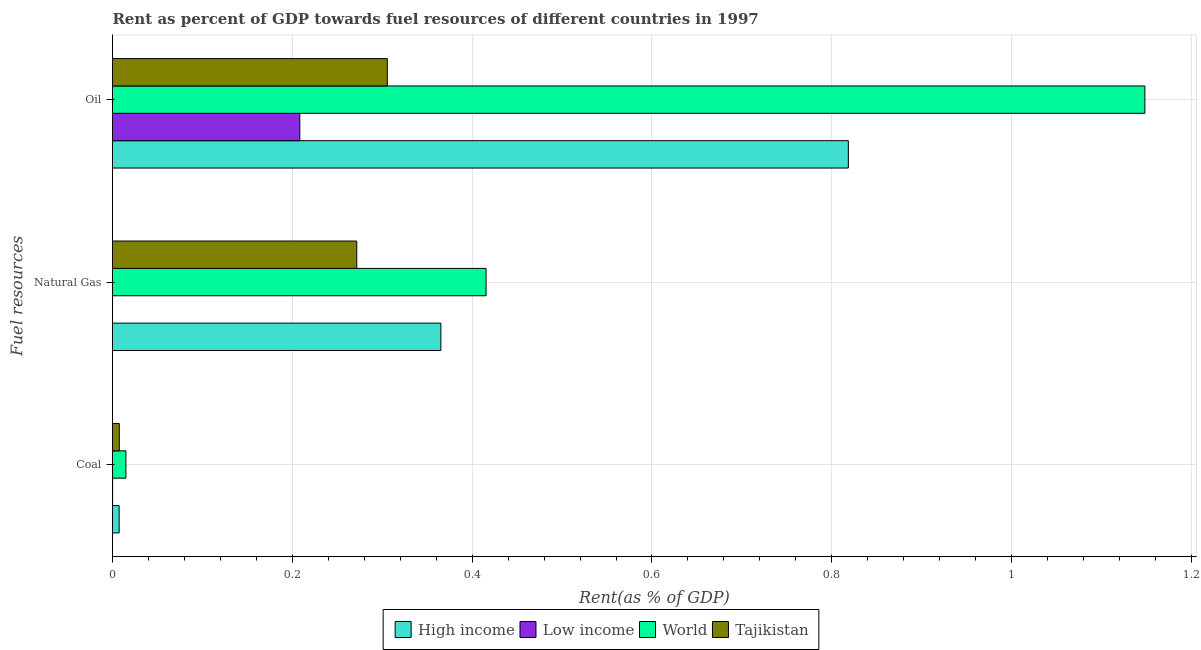How many different coloured bars are there?
Make the answer very short. 4. Are the number of bars per tick equal to the number of legend labels?
Give a very brief answer. Yes. How many bars are there on the 3rd tick from the top?
Offer a very short reply. 4. What is the label of the 2nd group of bars from the top?
Your answer should be compact. Natural Gas. What is the rent towards oil in Tajikistan?
Ensure brevity in your answer.  0.31. Across all countries, what is the maximum rent towards oil?
Offer a very short reply. 1.15. Across all countries, what is the minimum rent towards coal?
Ensure brevity in your answer.  0. In which country was the rent towards oil maximum?
Keep it short and to the point. World. In which country was the rent towards oil minimum?
Provide a short and direct response. Low income. What is the total rent towards oil in the graph?
Keep it short and to the point. 2.48. What is the difference between the rent towards natural gas in World and that in Tajikistan?
Keep it short and to the point. 0.14. What is the difference between the rent towards oil in Tajikistan and the rent towards natural gas in World?
Your answer should be very brief. -0.11. What is the average rent towards coal per country?
Ensure brevity in your answer.  0.01. What is the difference between the rent towards oil and rent towards natural gas in World?
Offer a very short reply. 0.73. What is the ratio of the rent towards natural gas in Tajikistan to that in Low income?
Your answer should be compact. 7077.59. Is the rent towards coal in Low income less than that in High income?
Provide a short and direct response. Yes. Is the difference between the rent towards natural gas in High income and Tajikistan greater than the difference between the rent towards oil in High income and Tajikistan?
Offer a very short reply. No. What is the difference between the highest and the second highest rent towards oil?
Provide a short and direct response. 0.33. What is the difference between the highest and the lowest rent towards coal?
Your response must be concise. 0.01. In how many countries, is the rent towards natural gas greater than the average rent towards natural gas taken over all countries?
Make the answer very short. 3. Is the sum of the rent towards coal in Low income and World greater than the maximum rent towards natural gas across all countries?
Give a very brief answer. No. What does the 3rd bar from the top in Natural Gas represents?
Offer a very short reply. Low income. Is it the case that in every country, the sum of the rent towards coal and rent towards natural gas is greater than the rent towards oil?
Keep it short and to the point. No. How many bars are there?
Ensure brevity in your answer.  12. How many countries are there in the graph?
Give a very brief answer. 4. Are the values on the major ticks of X-axis written in scientific E-notation?
Provide a succinct answer. No. Where does the legend appear in the graph?
Offer a terse response. Bottom center. What is the title of the graph?
Your answer should be compact. Rent as percent of GDP towards fuel resources of different countries in 1997. Does "Moldova" appear as one of the legend labels in the graph?
Offer a terse response. No. What is the label or title of the X-axis?
Your answer should be very brief. Rent(as % of GDP). What is the label or title of the Y-axis?
Your answer should be compact. Fuel resources. What is the Rent(as % of GDP) in High income in Coal?
Your answer should be very brief. 0.01. What is the Rent(as % of GDP) of Low income in Coal?
Offer a very short reply. 0. What is the Rent(as % of GDP) of World in Coal?
Your answer should be very brief. 0.01. What is the Rent(as % of GDP) in Tajikistan in Coal?
Your answer should be compact. 0.01. What is the Rent(as % of GDP) of High income in Natural Gas?
Your answer should be very brief. 0.37. What is the Rent(as % of GDP) in Low income in Natural Gas?
Provide a short and direct response. 3.83841350463664e-5. What is the Rent(as % of GDP) of World in Natural Gas?
Offer a very short reply. 0.42. What is the Rent(as % of GDP) of Tajikistan in Natural Gas?
Your answer should be compact. 0.27. What is the Rent(as % of GDP) of High income in Oil?
Provide a succinct answer. 0.82. What is the Rent(as % of GDP) of Low income in Oil?
Keep it short and to the point. 0.21. What is the Rent(as % of GDP) in World in Oil?
Your answer should be very brief. 1.15. What is the Rent(as % of GDP) of Tajikistan in Oil?
Your answer should be very brief. 0.31. Across all Fuel resources, what is the maximum Rent(as % of GDP) in High income?
Offer a terse response. 0.82. Across all Fuel resources, what is the maximum Rent(as % of GDP) of Low income?
Give a very brief answer. 0.21. Across all Fuel resources, what is the maximum Rent(as % of GDP) in World?
Ensure brevity in your answer.  1.15. Across all Fuel resources, what is the maximum Rent(as % of GDP) in Tajikistan?
Give a very brief answer. 0.31. Across all Fuel resources, what is the minimum Rent(as % of GDP) of High income?
Provide a succinct answer. 0.01. Across all Fuel resources, what is the minimum Rent(as % of GDP) of Low income?
Your response must be concise. 3.83841350463664e-5. Across all Fuel resources, what is the minimum Rent(as % of GDP) of World?
Your response must be concise. 0.01. Across all Fuel resources, what is the minimum Rent(as % of GDP) in Tajikistan?
Keep it short and to the point. 0.01. What is the total Rent(as % of GDP) in High income in the graph?
Offer a very short reply. 1.19. What is the total Rent(as % of GDP) in Low income in the graph?
Give a very brief answer. 0.21. What is the total Rent(as % of GDP) in World in the graph?
Give a very brief answer. 1.58. What is the total Rent(as % of GDP) of Tajikistan in the graph?
Your answer should be very brief. 0.58. What is the difference between the Rent(as % of GDP) of High income in Coal and that in Natural Gas?
Provide a succinct answer. -0.36. What is the difference between the Rent(as % of GDP) of World in Coal and that in Natural Gas?
Your answer should be very brief. -0.4. What is the difference between the Rent(as % of GDP) in Tajikistan in Coal and that in Natural Gas?
Make the answer very short. -0.26. What is the difference between the Rent(as % of GDP) of High income in Coal and that in Oil?
Your response must be concise. -0.81. What is the difference between the Rent(as % of GDP) of Low income in Coal and that in Oil?
Make the answer very short. -0.21. What is the difference between the Rent(as % of GDP) in World in Coal and that in Oil?
Make the answer very short. -1.13. What is the difference between the Rent(as % of GDP) of Tajikistan in Coal and that in Oil?
Ensure brevity in your answer.  -0.3. What is the difference between the Rent(as % of GDP) of High income in Natural Gas and that in Oil?
Ensure brevity in your answer.  -0.45. What is the difference between the Rent(as % of GDP) in Low income in Natural Gas and that in Oil?
Your answer should be compact. -0.21. What is the difference between the Rent(as % of GDP) in World in Natural Gas and that in Oil?
Provide a succinct answer. -0.73. What is the difference between the Rent(as % of GDP) of Tajikistan in Natural Gas and that in Oil?
Give a very brief answer. -0.03. What is the difference between the Rent(as % of GDP) of High income in Coal and the Rent(as % of GDP) of Low income in Natural Gas?
Ensure brevity in your answer.  0.01. What is the difference between the Rent(as % of GDP) in High income in Coal and the Rent(as % of GDP) in World in Natural Gas?
Your answer should be compact. -0.41. What is the difference between the Rent(as % of GDP) of High income in Coal and the Rent(as % of GDP) of Tajikistan in Natural Gas?
Provide a succinct answer. -0.26. What is the difference between the Rent(as % of GDP) in Low income in Coal and the Rent(as % of GDP) in World in Natural Gas?
Your response must be concise. -0.42. What is the difference between the Rent(as % of GDP) in Low income in Coal and the Rent(as % of GDP) in Tajikistan in Natural Gas?
Ensure brevity in your answer.  -0.27. What is the difference between the Rent(as % of GDP) of World in Coal and the Rent(as % of GDP) of Tajikistan in Natural Gas?
Your answer should be compact. -0.26. What is the difference between the Rent(as % of GDP) of High income in Coal and the Rent(as % of GDP) of Low income in Oil?
Your answer should be very brief. -0.2. What is the difference between the Rent(as % of GDP) in High income in Coal and the Rent(as % of GDP) in World in Oil?
Your answer should be compact. -1.14. What is the difference between the Rent(as % of GDP) of High income in Coal and the Rent(as % of GDP) of Tajikistan in Oil?
Ensure brevity in your answer.  -0.3. What is the difference between the Rent(as % of GDP) of Low income in Coal and the Rent(as % of GDP) of World in Oil?
Ensure brevity in your answer.  -1.15. What is the difference between the Rent(as % of GDP) of Low income in Coal and the Rent(as % of GDP) of Tajikistan in Oil?
Provide a succinct answer. -0.31. What is the difference between the Rent(as % of GDP) in World in Coal and the Rent(as % of GDP) in Tajikistan in Oil?
Provide a short and direct response. -0.29. What is the difference between the Rent(as % of GDP) of High income in Natural Gas and the Rent(as % of GDP) of Low income in Oil?
Make the answer very short. 0.16. What is the difference between the Rent(as % of GDP) in High income in Natural Gas and the Rent(as % of GDP) in World in Oil?
Ensure brevity in your answer.  -0.78. What is the difference between the Rent(as % of GDP) of High income in Natural Gas and the Rent(as % of GDP) of Tajikistan in Oil?
Provide a short and direct response. 0.06. What is the difference between the Rent(as % of GDP) in Low income in Natural Gas and the Rent(as % of GDP) in World in Oil?
Your response must be concise. -1.15. What is the difference between the Rent(as % of GDP) in Low income in Natural Gas and the Rent(as % of GDP) in Tajikistan in Oil?
Ensure brevity in your answer.  -0.31. What is the difference between the Rent(as % of GDP) of World in Natural Gas and the Rent(as % of GDP) of Tajikistan in Oil?
Provide a short and direct response. 0.11. What is the average Rent(as % of GDP) of High income per Fuel resources?
Your answer should be compact. 0.4. What is the average Rent(as % of GDP) in Low income per Fuel resources?
Offer a terse response. 0.07. What is the average Rent(as % of GDP) in World per Fuel resources?
Your answer should be very brief. 0.53. What is the average Rent(as % of GDP) in Tajikistan per Fuel resources?
Your answer should be very brief. 0.2. What is the difference between the Rent(as % of GDP) in High income and Rent(as % of GDP) in Low income in Coal?
Provide a short and direct response. 0.01. What is the difference between the Rent(as % of GDP) in High income and Rent(as % of GDP) in World in Coal?
Your answer should be very brief. -0.01. What is the difference between the Rent(as % of GDP) in High income and Rent(as % of GDP) in Tajikistan in Coal?
Your response must be concise. -0. What is the difference between the Rent(as % of GDP) of Low income and Rent(as % of GDP) of World in Coal?
Your response must be concise. -0.01. What is the difference between the Rent(as % of GDP) of Low income and Rent(as % of GDP) of Tajikistan in Coal?
Give a very brief answer. -0.01. What is the difference between the Rent(as % of GDP) of World and Rent(as % of GDP) of Tajikistan in Coal?
Keep it short and to the point. 0.01. What is the difference between the Rent(as % of GDP) in High income and Rent(as % of GDP) in Low income in Natural Gas?
Give a very brief answer. 0.37. What is the difference between the Rent(as % of GDP) of High income and Rent(as % of GDP) of World in Natural Gas?
Ensure brevity in your answer.  -0.05. What is the difference between the Rent(as % of GDP) in High income and Rent(as % of GDP) in Tajikistan in Natural Gas?
Provide a succinct answer. 0.09. What is the difference between the Rent(as % of GDP) of Low income and Rent(as % of GDP) of World in Natural Gas?
Your response must be concise. -0.42. What is the difference between the Rent(as % of GDP) of Low income and Rent(as % of GDP) of Tajikistan in Natural Gas?
Ensure brevity in your answer.  -0.27. What is the difference between the Rent(as % of GDP) in World and Rent(as % of GDP) in Tajikistan in Natural Gas?
Your answer should be compact. 0.14. What is the difference between the Rent(as % of GDP) of High income and Rent(as % of GDP) of Low income in Oil?
Provide a succinct answer. 0.61. What is the difference between the Rent(as % of GDP) in High income and Rent(as % of GDP) in World in Oil?
Provide a short and direct response. -0.33. What is the difference between the Rent(as % of GDP) in High income and Rent(as % of GDP) in Tajikistan in Oil?
Offer a terse response. 0.51. What is the difference between the Rent(as % of GDP) in Low income and Rent(as % of GDP) in World in Oil?
Ensure brevity in your answer.  -0.94. What is the difference between the Rent(as % of GDP) in Low income and Rent(as % of GDP) in Tajikistan in Oil?
Provide a succinct answer. -0.1. What is the difference between the Rent(as % of GDP) in World and Rent(as % of GDP) in Tajikistan in Oil?
Ensure brevity in your answer.  0.84. What is the ratio of the Rent(as % of GDP) in High income in Coal to that in Natural Gas?
Ensure brevity in your answer.  0.02. What is the ratio of the Rent(as % of GDP) of Low income in Coal to that in Natural Gas?
Make the answer very short. 3.22. What is the ratio of the Rent(as % of GDP) of World in Coal to that in Natural Gas?
Keep it short and to the point. 0.04. What is the ratio of the Rent(as % of GDP) in Tajikistan in Coal to that in Natural Gas?
Provide a short and direct response. 0.03. What is the ratio of the Rent(as % of GDP) of High income in Coal to that in Oil?
Offer a terse response. 0.01. What is the ratio of the Rent(as % of GDP) of Low income in Coal to that in Oil?
Ensure brevity in your answer.  0. What is the ratio of the Rent(as % of GDP) in World in Coal to that in Oil?
Provide a short and direct response. 0.01. What is the ratio of the Rent(as % of GDP) in Tajikistan in Coal to that in Oil?
Your response must be concise. 0.02. What is the ratio of the Rent(as % of GDP) of High income in Natural Gas to that in Oil?
Give a very brief answer. 0.45. What is the ratio of the Rent(as % of GDP) in World in Natural Gas to that in Oil?
Keep it short and to the point. 0.36. What is the ratio of the Rent(as % of GDP) of Tajikistan in Natural Gas to that in Oil?
Your answer should be very brief. 0.89. What is the difference between the highest and the second highest Rent(as % of GDP) in High income?
Your answer should be very brief. 0.45. What is the difference between the highest and the second highest Rent(as % of GDP) in Low income?
Ensure brevity in your answer.  0.21. What is the difference between the highest and the second highest Rent(as % of GDP) of World?
Make the answer very short. 0.73. What is the difference between the highest and the second highest Rent(as % of GDP) of Tajikistan?
Keep it short and to the point. 0.03. What is the difference between the highest and the lowest Rent(as % of GDP) of High income?
Provide a succinct answer. 0.81. What is the difference between the highest and the lowest Rent(as % of GDP) of Low income?
Offer a terse response. 0.21. What is the difference between the highest and the lowest Rent(as % of GDP) in World?
Your answer should be compact. 1.13. What is the difference between the highest and the lowest Rent(as % of GDP) of Tajikistan?
Give a very brief answer. 0.3. 